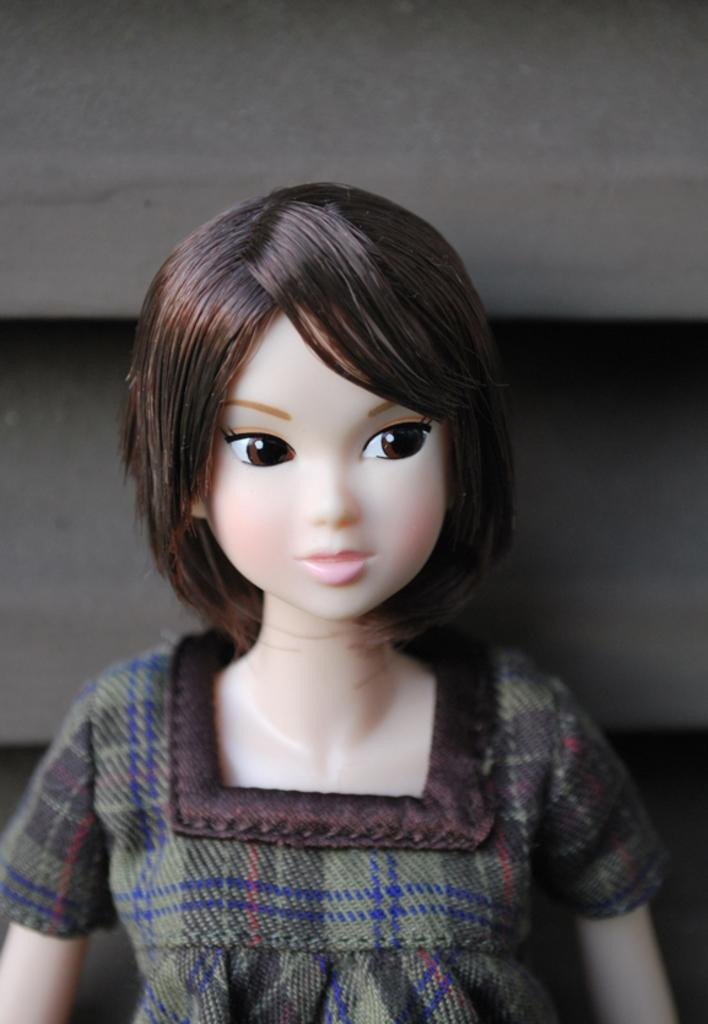What is the main subject of the picture? The main subject of the picture is a doll. Can you describe the doll in the picture? The doll is of a woman and is wearing a dress. What else can be seen in the background of the image? There are other objects in the background of the image. What type of education does the doll have in the image? There is no indication of the doll's education in the image, as it is a doll and not a real person. What happens when the doll bursts in the image? There is no indication of the doll bursting in the image, as it is a doll and not a real person or object that can burst. 